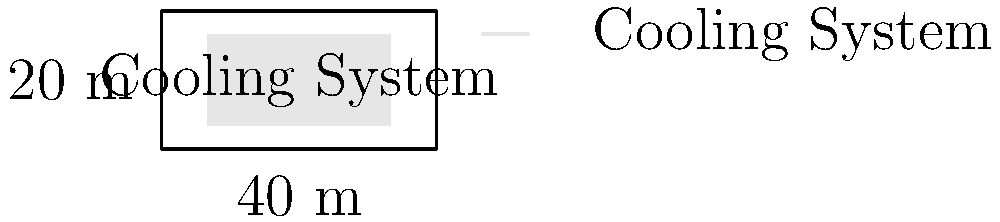As you reminisce about your days as a Williams Ephs ice hockey fan, you recall the importance of maintaining the perfect ice conditions. The college's ice rink measures 40 m by 20 m. If the cooling system operates at 150 kW and runs for 18 hours a day, what is the daily energy consumption in kilowatt-hours (kWh)? To calculate the daily energy consumption of the ice rink's cooling system, we need to follow these steps:

1. Identify the given information:
   - Cooling system power: $P = 150$ kW
   - Daily operation time: $t = 18$ hours

2. Recall the formula for energy consumption:
   $E = P \times t$
   Where:
   $E$ is energy in kilowatt-hours (kWh)
   $P$ is power in kilowatts (kW)
   $t$ is time in hours (h)

3. Substitute the values into the formula:
   $E = 150 \text{ kW} \times 18 \text{ h}$

4. Perform the calculation:
   $E = 2700 \text{ kWh}$

Thus, the daily energy consumption of the ice rink's cooling system is 2700 kWh.
Answer: 2700 kWh 